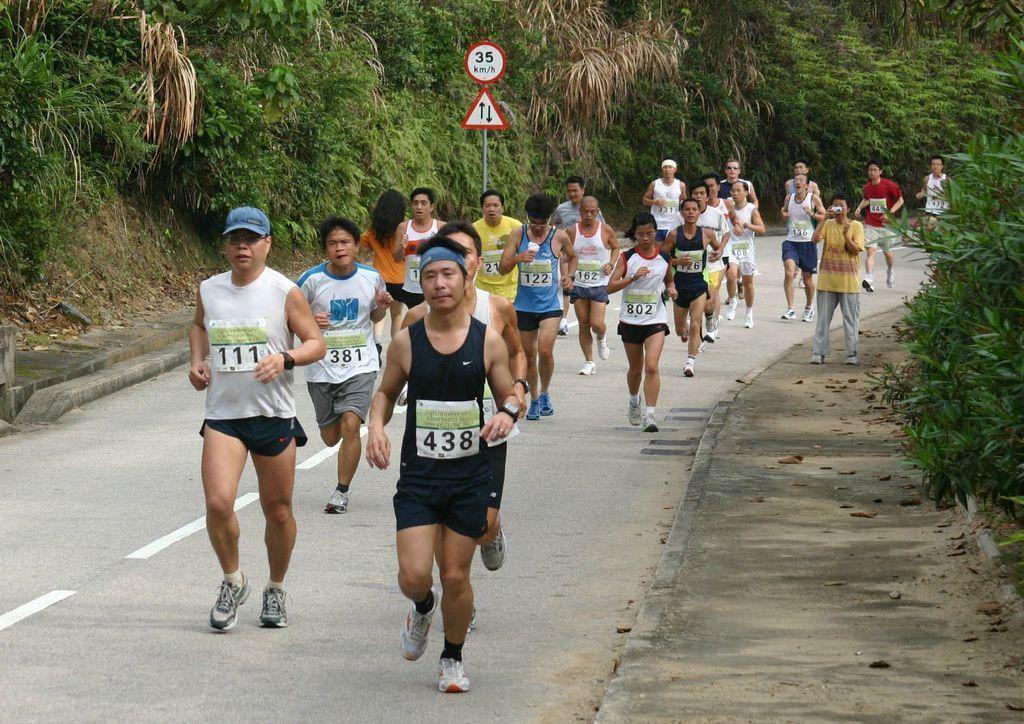Could you give a brief overview of what you see in this image? in this image there are some persons running as we can see in middle of this image and there is a road in middle of this image and there are some white color lines in middle of this road. There is a sign board in top middle of this image and there are some trees in the background. 